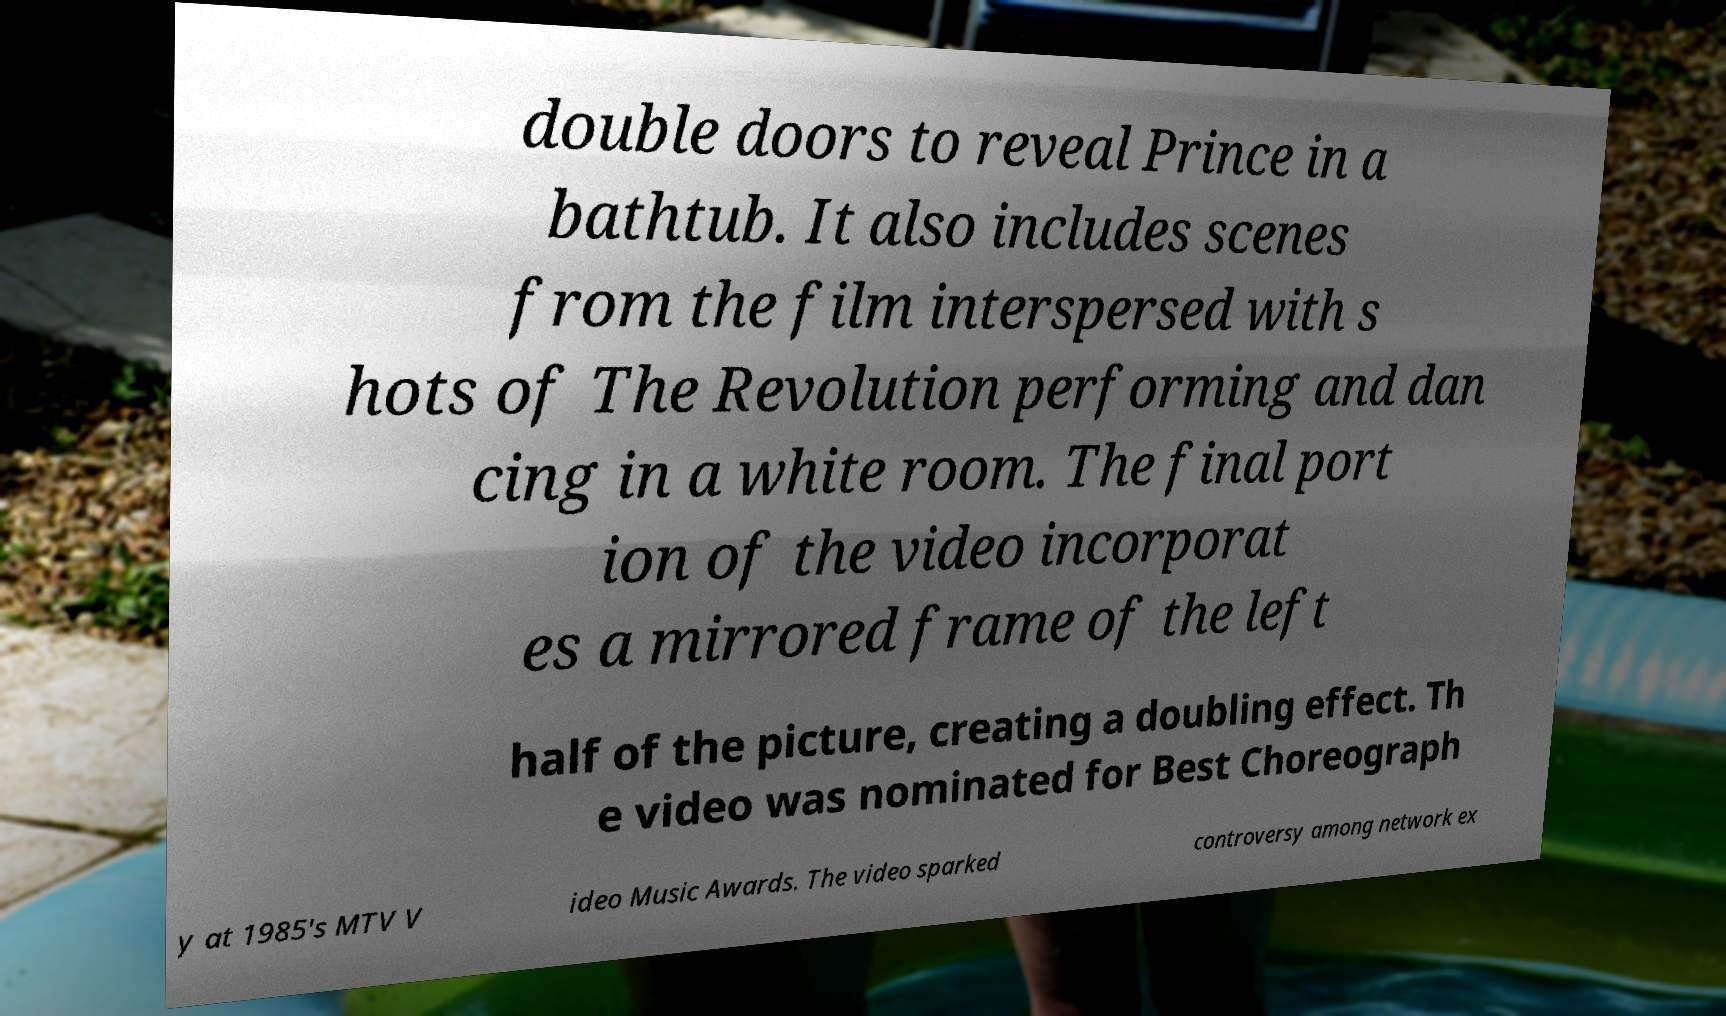I need the written content from this picture converted into text. Can you do that? double doors to reveal Prince in a bathtub. It also includes scenes from the film interspersed with s hots of The Revolution performing and dan cing in a white room. The final port ion of the video incorporat es a mirrored frame of the left half of the picture, creating a doubling effect. Th e video was nominated for Best Choreograph y at 1985's MTV V ideo Music Awards. The video sparked controversy among network ex 